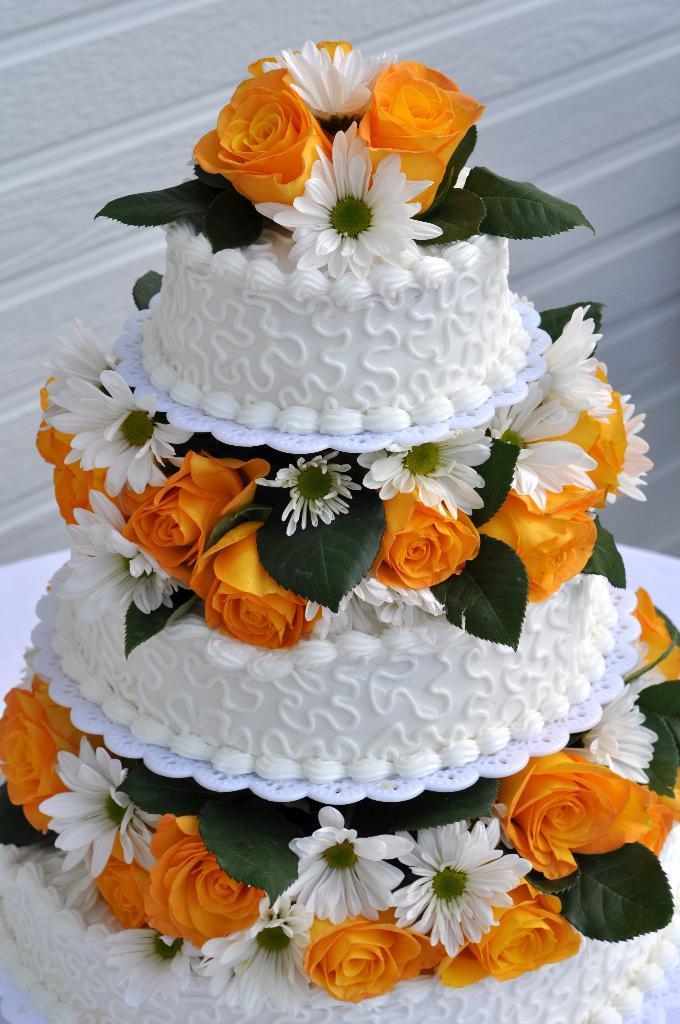In one or two sentences, can you explain what this image depicts? In this image there is a cake placed on the table. In the middle and top of the cake there are flowers. In the background there is a wall. 